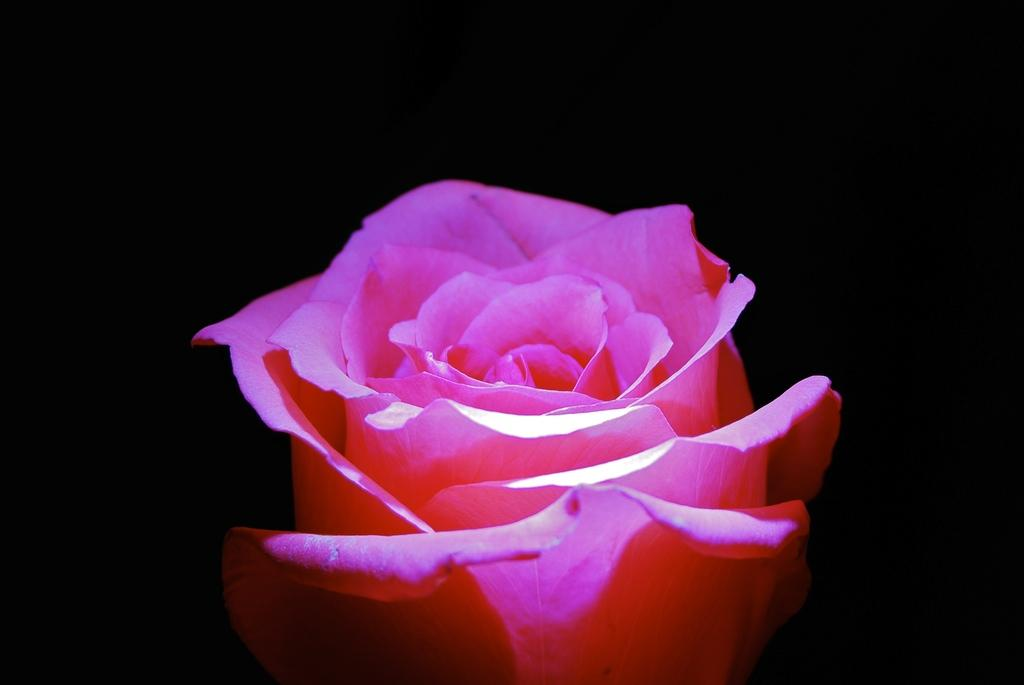What type of flowers can be seen in the image? There are pink flowers in the image. What is the color of the background in the image? The background of the image is dark. What type of yarn is used to create the scent of the flowers in the image? There is no yarn present in the image, and flowers do not use yarn to create their scent. 